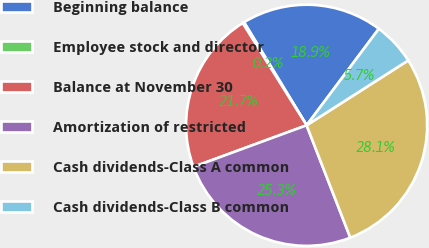Convert chart to OTSL. <chart><loc_0><loc_0><loc_500><loc_500><pie_chart><fcel>Beginning balance<fcel>Employee stock and director<fcel>Balance at November 30<fcel>Amortization of restricted<fcel>Cash dividends-Class A common<fcel>Cash dividends-Class B common<nl><fcel>18.91%<fcel>0.21%<fcel>21.71%<fcel>25.3%<fcel>28.14%<fcel>5.73%<nl></chart> 